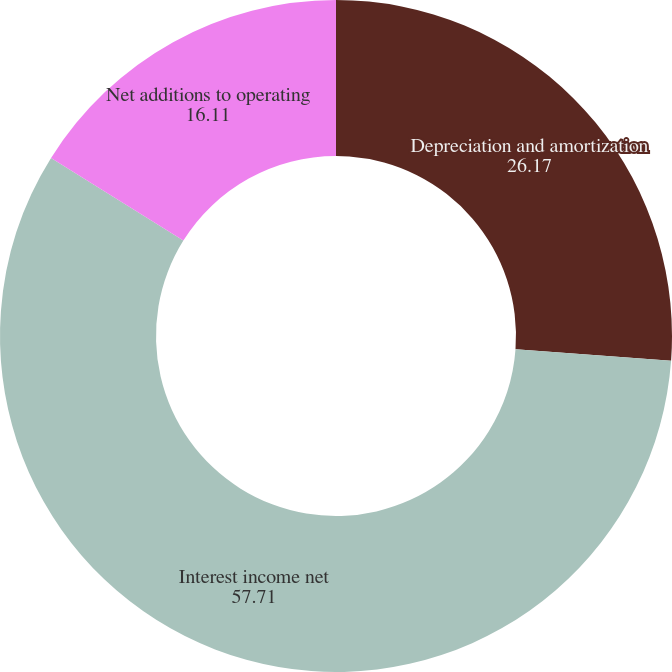Convert chart. <chart><loc_0><loc_0><loc_500><loc_500><pie_chart><fcel>Depreciation and amortization<fcel>Interest income net<fcel>Net additions to operating<nl><fcel>26.17%<fcel>57.71%<fcel>16.11%<nl></chart> 